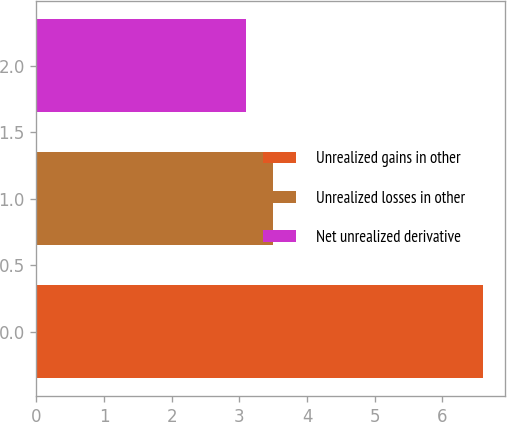<chart> <loc_0><loc_0><loc_500><loc_500><bar_chart><fcel>Unrealized gains in other<fcel>Unrealized losses in other<fcel>Net unrealized derivative<nl><fcel>6.6<fcel>3.5<fcel>3.1<nl></chart> 